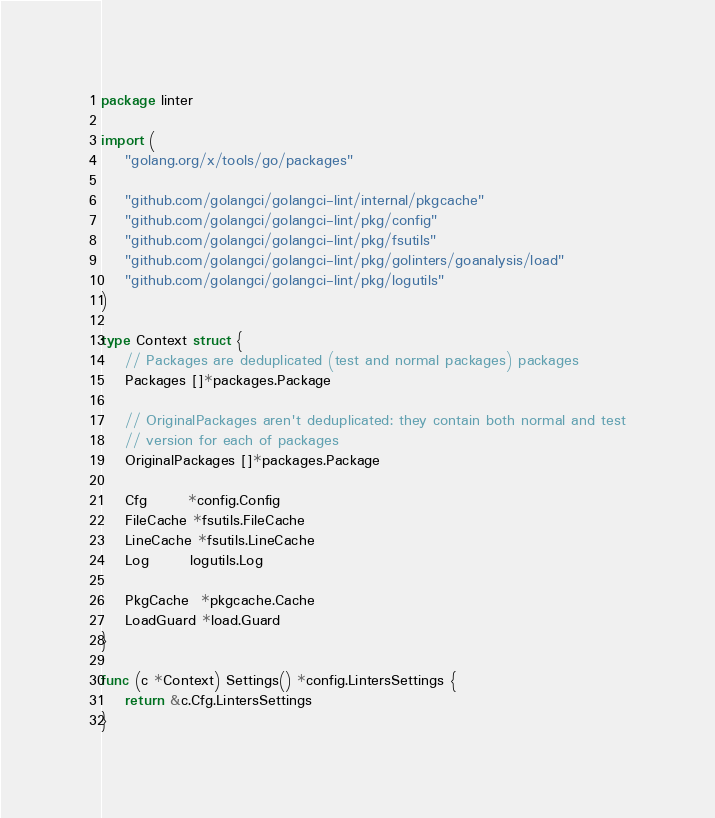Convert code to text. <code><loc_0><loc_0><loc_500><loc_500><_Go_>package linter

import (
	"golang.org/x/tools/go/packages"

	"github.com/golangci/golangci-lint/internal/pkgcache"
	"github.com/golangci/golangci-lint/pkg/config"
	"github.com/golangci/golangci-lint/pkg/fsutils"
	"github.com/golangci/golangci-lint/pkg/golinters/goanalysis/load"
	"github.com/golangci/golangci-lint/pkg/logutils"
)

type Context struct {
	// Packages are deduplicated (test and normal packages) packages
	Packages []*packages.Package

	// OriginalPackages aren't deduplicated: they contain both normal and test
	// version for each of packages
	OriginalPackages []*packages.Package

	Cfg       *config.Config
	FileCache *fsutils.FileCache
	LineCache *fsutils.LineCache
	Log       logutils.Log

	PkgCache  *pkgcache.Cache
	LoadGuard *load.Guard
}

func (c *Context) Settings() *config.LintersSettings {
	return &c.Cfg.LintersSettings
}
</code> 